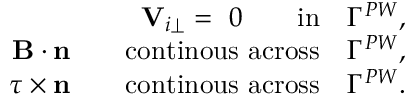Convert formula to latex. <formula><loc_0><loc_0><loc_500><loc_500>\begin{array} { r } { { \mathbf V } _ { i \perp } = 0 \quad i n \quad \Gamma ^ { P W } , } \\ { { \mathbf B } \cdot n \quad c o n t i n o u s a c r o s s \quad \Gamma ^ { P W } , } \\ { \tau \times n \quad c o n t i n o u s a c r o s s \quad \Gamma ^ { P W } . } \end{array}</formula> 